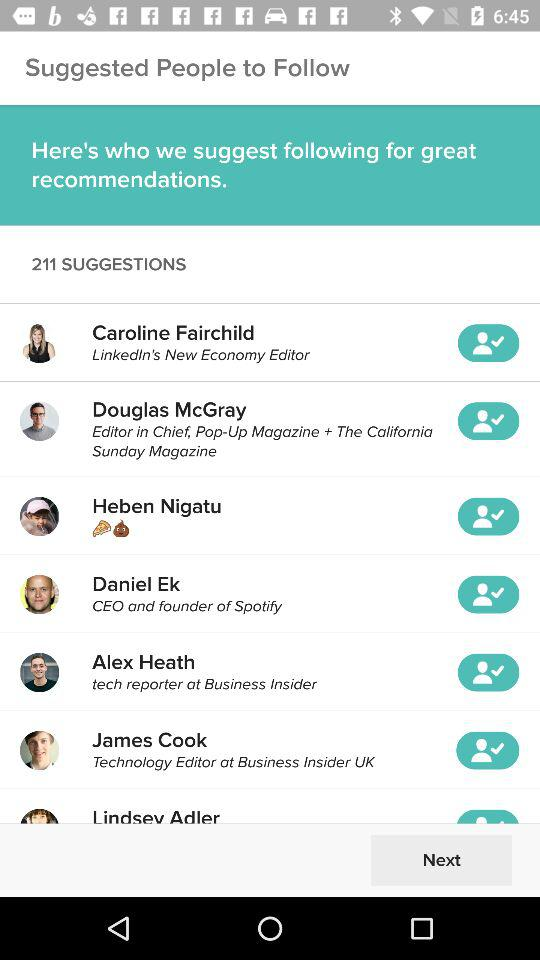Where does Heben Nigatu work?
When the provided information is insufficient, respond with <no answer>. <no answer> 